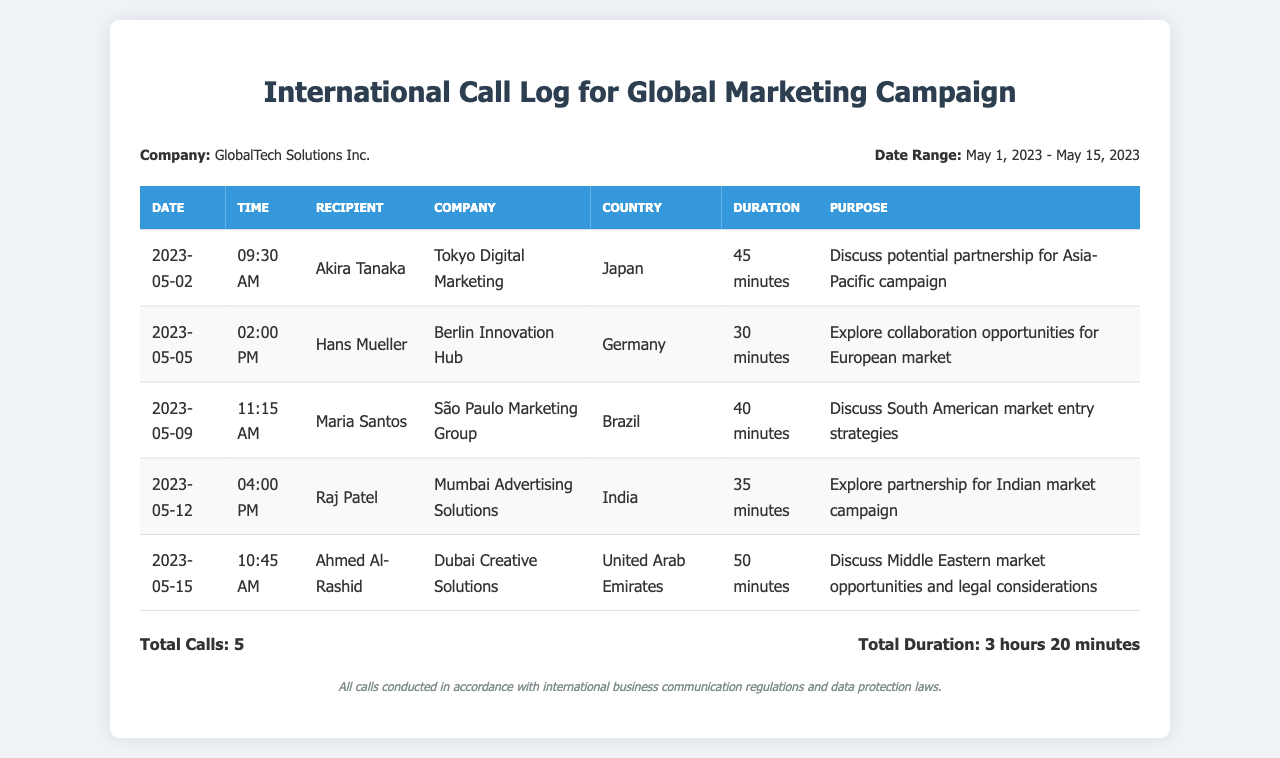What is the date of the first call? The first call listed in the document was made on May 2, 2023.
Answer: May 2, 2023 Who was the recipient of the call on May 5, 2023? The recipient of the call on this date was Hans Mueller.
Answer: Hans Mueller What is the total duration of all calls? The document states that the total duration of all calls made is 3 hours 20 minutes.
Answer: 3 hours 20 minutes Which country was discussed in the call with Maria Santos? The call with Maria Santos discussed the South American market, specifically Brazil.
Answer: Brazil What company is associated with Ahmed Al-Rashid? The company associated with Ahmed Al-Rashid is Dubai Creative Solutions.
Answer: Dubai Creative Solutions How many calls were made to partners in Asia? The log indicates one call was made to a partner in Asia, specifically to Tokyo Digital Marketing.
Answer: 1 What was the main purpose of the call with Raj Patel? The main purpose was to explore partnership for the Indian market campaign.
Answer: Explore partnership for Indian market campaign What time was the call with Akira Tanaka? The call with Akira Tanaka took place at 09:30 AM.
Answer: 09:30 AM What is the legal note mentioned in the document? The legal note states that all calls were conducted in accordance with international business communication regulations and data protection laws.
Answer: All calls conducted in accordance with international business communication regulations and data protection laws 